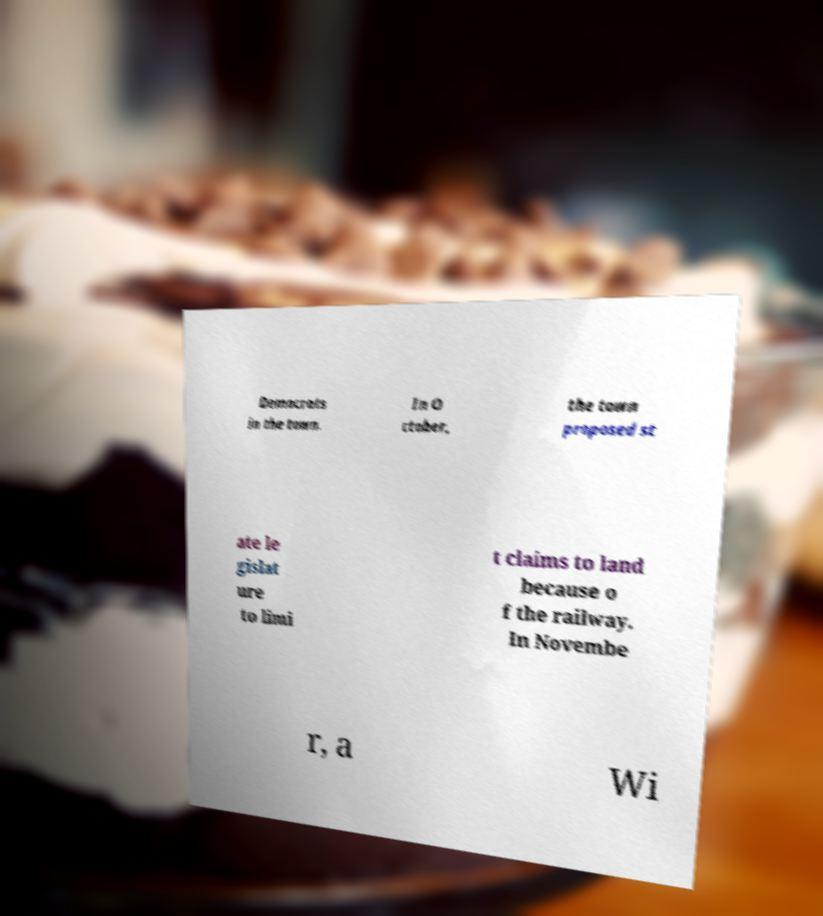Can you read and provide the text displayed in the image?This photo seems to have some interesting text. Can you extract and type it out for me? Democrats in the town. In O ctober, the town proposed st ate le gislat ure to limi t claims to land because o f the railway. In Novembe r, a Wi 